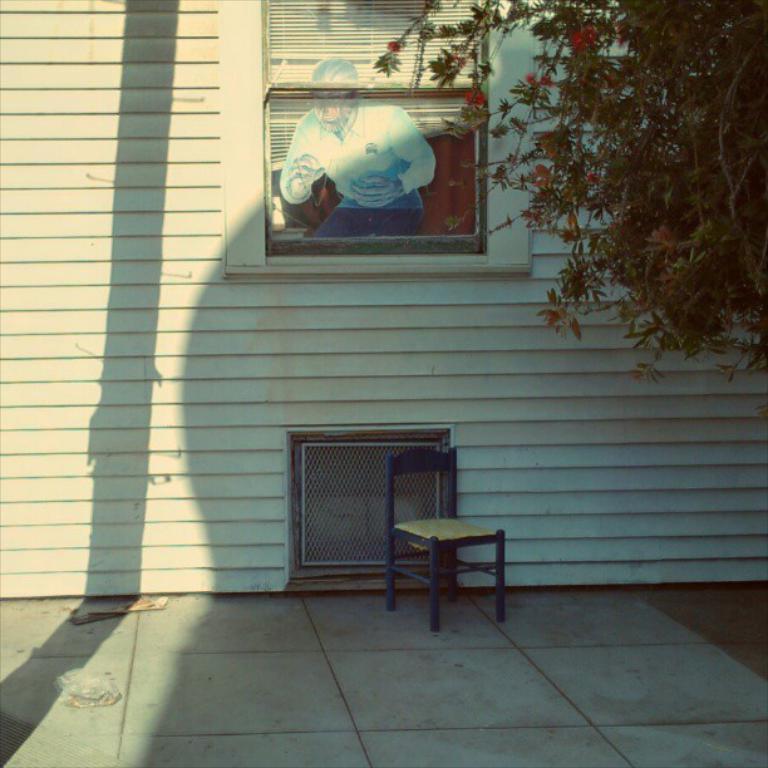Please provide a concise description of this image. In this image, we can see the wall with some windows and a sticker. We can see the ground with some objects. We can also see a chair. We can see a tree on the right. 